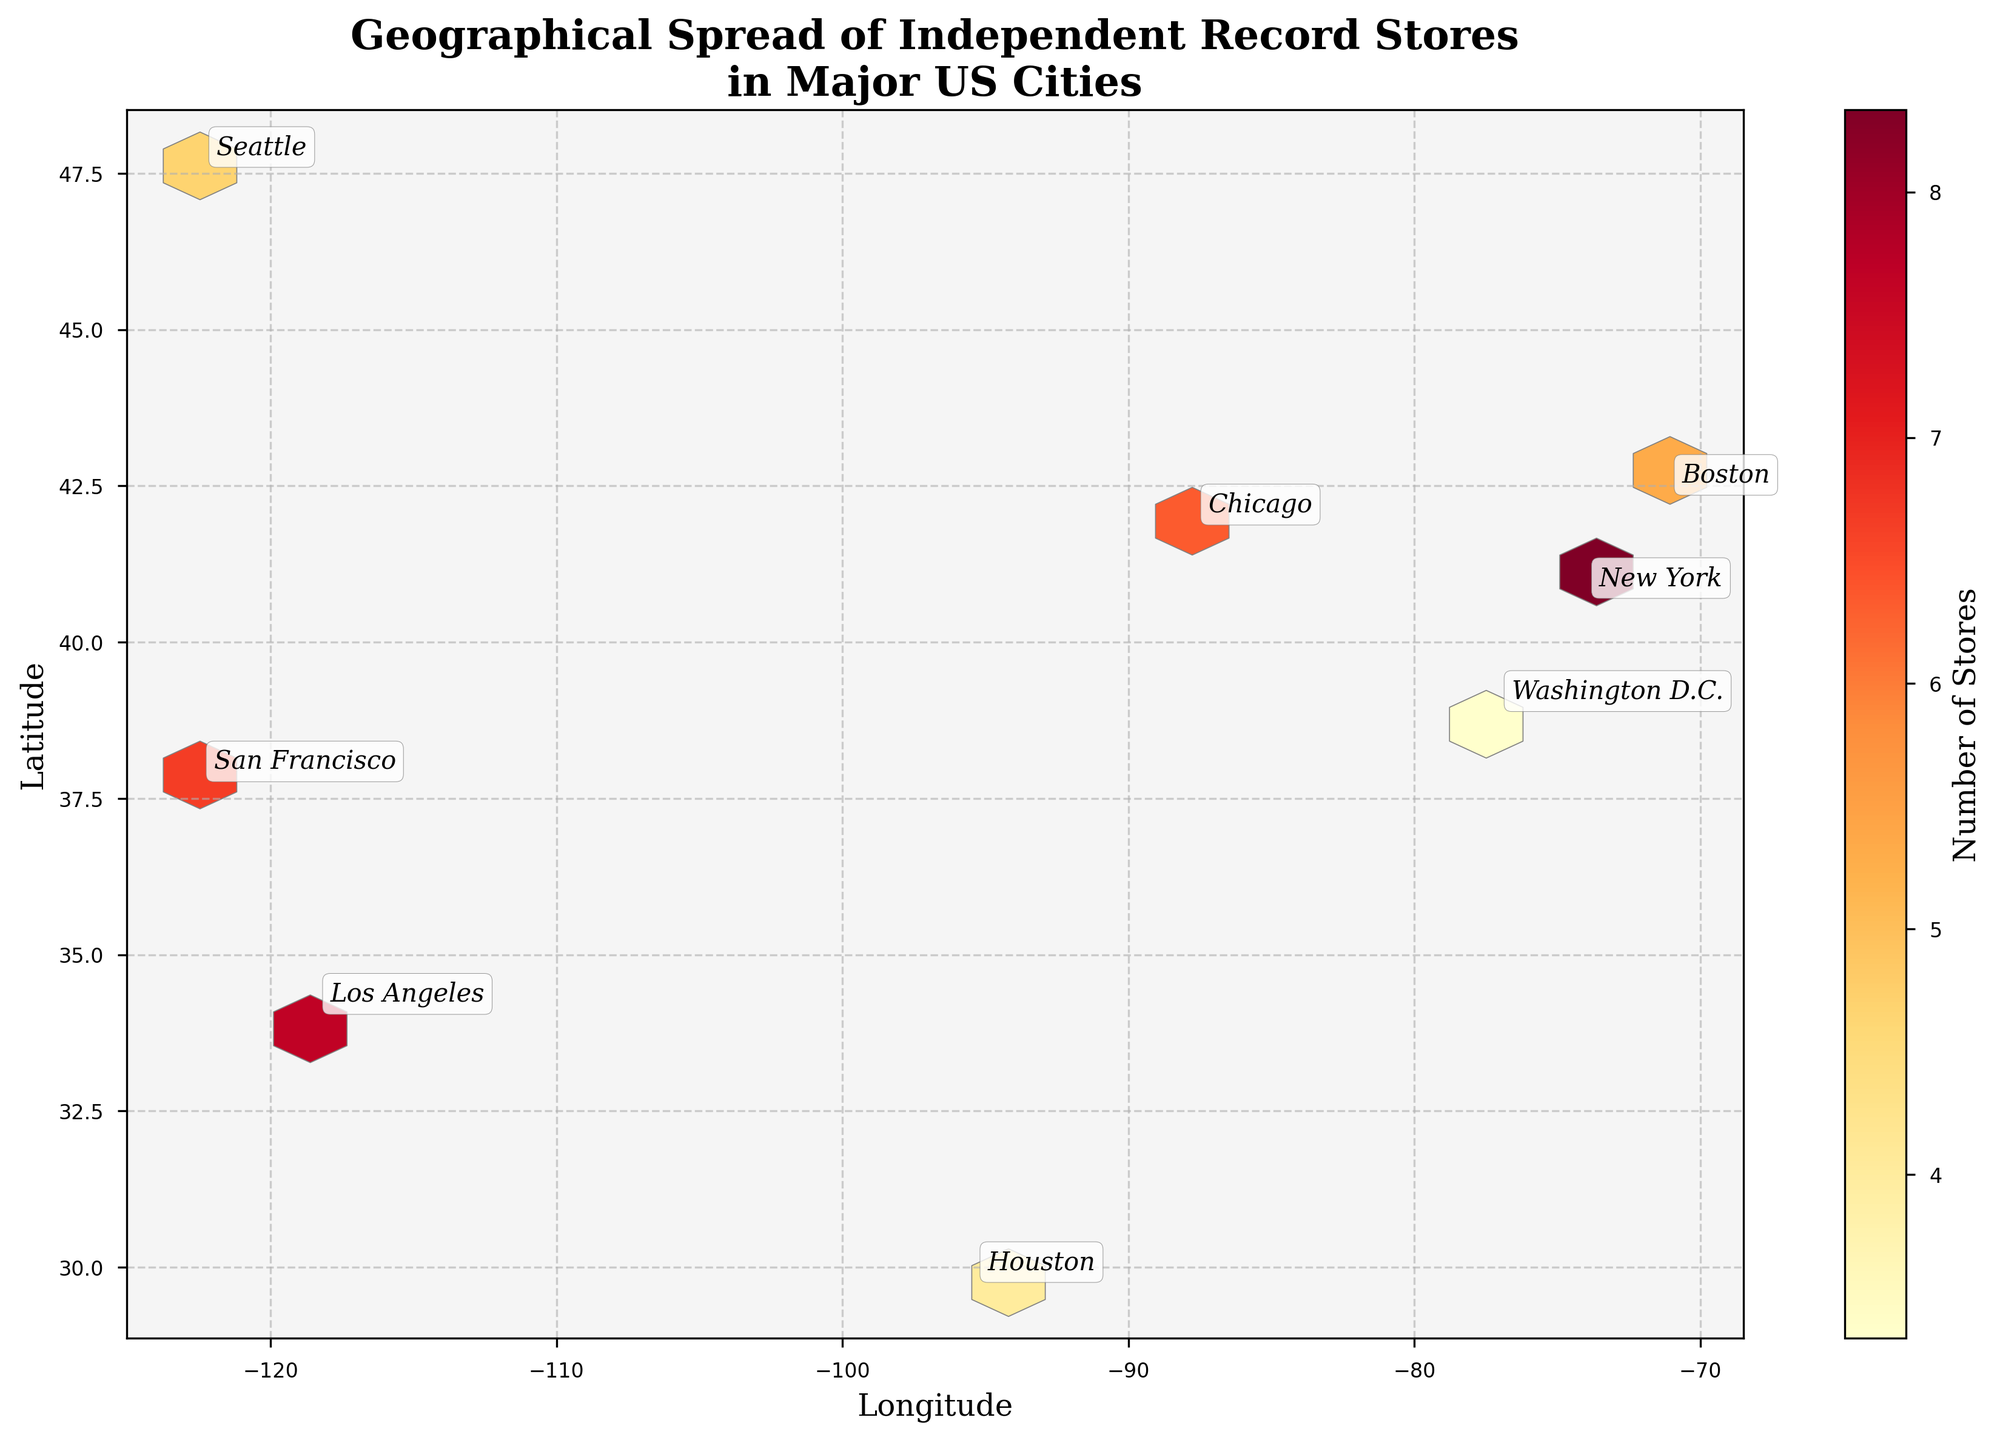Which city has the highest concentration of independent record stores? By looking at the hexbin plot, the color intensity indicates the number of stores. The number of stores is highest in areas with the most intense color, so we find the city label associated with that region.
Answer: New York What information is displayed on the color bar? The color bar shows the number of record stores as indicated by the color intensity in the hexbin plot. Areas with warmer colors (like red or orange) appear where there is a higher concentration of stores, while cooler colors (yellow) show lower concentrations.
Answer: Number of Stores Which city shows the widest geographical spread of record stores? We can determine geographical spread by examining how far apart the data points (hexagons) for each city are on the plot. This can be gauged by looking at the distance between annotations for the same city.
Answer: Los Angeles Which cities have been annotated on the hexbin plot and how can you tell? The annotations are the text labels on the plot. By scanning the plot for textual labels placed within bounding boxes, we can identify the cities.
Answer: New York, Chicago, Los Angeles, San Francisco, Boston, Seattle, Houston, Washington D.C Which city has the second highest average number of record stores? To determine averages, we look at the annotated city regions and compare their color intensity. First, identify the highest, then look for the next region with the most intense color.
Answer: San Francisco Of the cities listed, which one has the least geographical spread of record stores? To determine the city with the least spread, we assess how closely stacked the hexagons for each city are.
Answer: Houston How are Boston and Seattle represented in terms of geographical spread and store count? To compare these two cities, look at their annotations and the surrounding hexagon colors. Examine the spread and color intensity around Boston and Seattle labels.
Answer: Both Boston and Seattle have moderate spread and store counts; Boston shows higher concentration than Seattle What is the color used to indicate regions with lower concentrations of record stores? By examining the hexbin plot's color spectrum and related regions with lower store counts, we can identify the color representing lower densities.
Answer: Yellow 